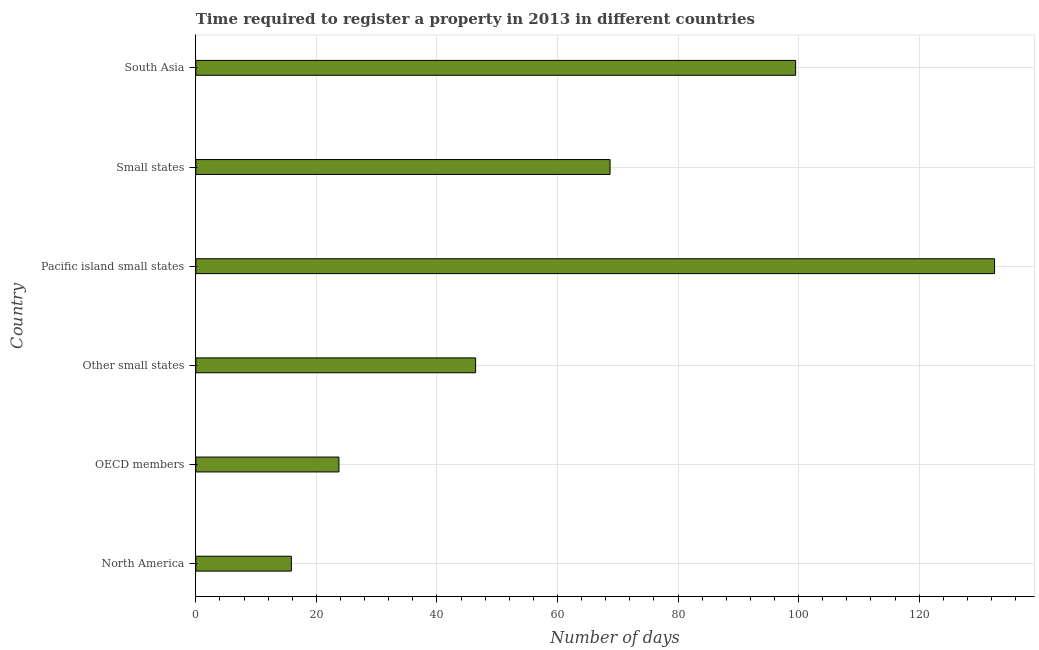Does the graph contain any zero values?
Provide a short and direct response. No. What is the title of the graph?
Provide a short and direct response. Time required to register a property in 2013 in different countries. What is the label or title of the X-axis?
Your answer should be compact. Number of days. What is the label or title of the Y-axis?
Offer a very short reply. Country. What is the number of days required to register property in Other small states?
Offer a terse response. 46.41. Across all countries, what is the maximum number of days required to register property?
Make the answer very short. 132.5. Across all countries, what is the minimum number of days required to register property?
Give a very brief answer. 15.85. In which country was the number of days required to register property maximum?
Ensure brevity in your answer.  Pacific island small states. In which country was the number of days required to register property minimum?
Provide a succinct answer. North America. What is the sum of the number of days required to register property?
Provide a succinct answer. 386.72. What is the difference between the number of days required to register property in OECD members and Pacific island small states?
Give a very brief answer. -108.76. What is the average number of days required to register property per country?
Ensure brevity in your answer.  64.45. What is the median number of days required to register property?
Your response must be concise. 57.56. In how many countries, is the number of days required to register property greater than 112 days?
Ensure brevity in your answer.  1. What is the ratio of the number of days required to register property in Pacific island small states to that in Small states?
Give a very brief answer. 1.93. Is the number of days required to register property in OECD members less than that in Pacific island small states?
Offer a terse response. Yes. Is the difference between the number of days required to register property in Small states and South Asia greater than the difference between any two countries?
Provide a succinct answer. No. What is the difference between the highest and the second highest number of days required to register property?
Keep it short and to the point. 33. What is the difference between the highest and the lowest number of days required to register property?
Give a very brief answer. 116.65. How many bars are there?
Ensure brevity in your answer.  6. How many countries are there in the graph?
Your answer should be compact. 6. What is the Number of days in North America?
Your answer should be very brief. 15.85. What is the Number of days of OECD members?
Give a very brief answer. 23.74. What is the Number of days in Other small states?
Provide a short and direct response. 46.41. What is the Number of days of Pacific island small states?
Give a very brief answer. 132.5. What is the Number of days in Small states?
Provide a short and direct response. 68.72. What is the Number of days of South Asia?
Keep it short and to the point. 99.5. What is the difference between the Number of days in North America and OECD members?
Provide a short and direct response. -7.89. What is the difference between the Number of days in North America and Other small states?
Make the answer very short. -30.56. What is the difference between the Number of days in North America and Pacific island small states?
Provide a short and direct response. -116.65. What is the difference between the Number of days in North America and Small states?
Your answer should be very brief. -52.87. What is the difference between the Number of days in North America and South Asia?
Provide a succinct answer. -83.65. What is the difference between the Number of days in OECD members and Other small states?
Provide a short and direct response. -22.67. What is the difference between the Number of days in OECD members and Pacific island small states?
Offer a very short reply. -108.76. What is the difference between the Number of days in OECD members and Small states?
Ensure brevity in your answer.  -44.98. What is the difference between the Number of days in OECD members and South Asia?
Your answer should be very brief. -75.76. What is the difference between the Number of days in Other small states and Pacific island small states?
Your answer should be compact. -86.09. What is the difference between the Number of days in Other small states and Small states?
Give a very brief answer. -22.3. What is the difference between the Number of days in Other small states and South Asia?
Provide a short and direct response. -53.09. What is the difference between the Number of days in Pacific island small states and Small states?
Make the answer very short. 63.78. What is the difference between the Number of days in Pacific island small states and South Asia?
Offer a very short reply. 33. What is the difference between the Number of days in Small states and South Asia?
Provide a succinct answer. -30.78. What is the ratio of the Number of days in North America to that in OECD members?
Your answer should be compact. 0.67. What is the ratio of the Number of days in North America to that in Other small states?
Provide a short and direct response. 0.34. What is the ratio of the Number of days in North America to that in Pacific island small states?
Offer a terse response. 0.12. What is the ratio of the Number of days in North America to that in Small states?
Offer a very short reply. 0.23. What is the ratio of the Number of days in North America to that in South Asia?
Keep it short and to the point. 0.16. What is the ratio of the Number of days in OECD members to that in Other small states?
Provide a short and direct response. 0.51. What is the ratio of the Number of days in OECD members to that in Pacific island small states?
Make the answer very short. 0.18. What is the ratio of the Number of days in OECD members to that in Small states?
Offer a terse response. 0.34. What is the ratio of the Number of days in OECD members to that in South Asia?
Your answer should be compact. 0.24. What is the ratio of the Number of days in Other small states to that in Small states?
Offer a very short reply. 0.68. What is the ratio of the Number of days in Other small states to that in South Asia?
Your answer should be very brief. 0.47. What is the ratio of the Number of days in Pacific island small states to that in Small states?
Offer a terse response. 1.93. What is the ratio of the Number of days in Pacific island small states to that in South Asia?
Ensure brevity in your answer.  1.33. What is the ratio of the Number of days in Small states to that in South Asia?
Make the answer very short. 0.69. 